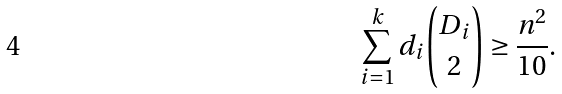Convert formula to latex. <formula><loc_0><loc_0><loc_500><loc_500>\sum _ { i = 1 } ^ { k } d _ { i } \binom { D _ { i } } { 2 } \geq \frac { n ^ { 2 } } { 1 0 } .</formula> 